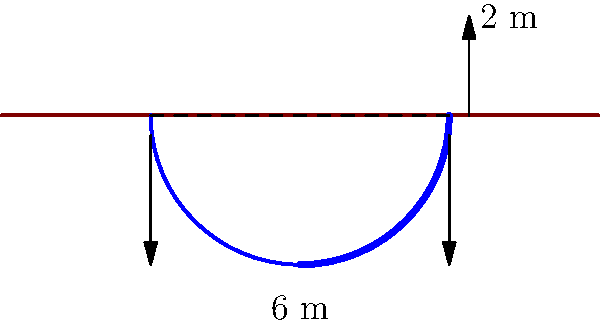During an excavation of an ancient fortress, you discover a partially buried cylindrical structure. The visible arc of the structure rises 2 meters above the ground, and the diameter of the base is 6 meters. Estimate the total volume of the cylindrical structure, assuming it extends uniformly below the ground. Round your answer to the nearest cubic meter. To estimate the volume of the cylindrical structure, we'll follow these steps:

1) First, we need to find the radius (r) of the base:
   Diameter = 6 m, so radius = 6/2 = 3 m

2) Next, we need to find the height (h) of the cylinder. We can do this using the Pythagorean theorem:
   $r^2 + (r-2)^2 = r^2$
   $3^2 + (3-2)^2 = 3^2$
   $9 + 1 = 9$
   
   This confirms that the visible part forms a right angle with the ground.

3) The total height is the diameter: h = 6 m

4) Now we can use the formula for the volume of a cylinder:
   $V = \pi r^2 h$

5) Plugging in our values:
   $V = \pi \cdot 3^2 \cdot 6$
   $V = \pi \cdot 9 \cdot 6$
   $V = 54\pi$

6) Calculating and rounding to the nearest cubic meter:
   $V \approx 169.65 \approx 170$ cubic meters

Therefore, the estimated volume of the cylindrical structure is approximately 170 cubic meters.
Answer: 170 cubic meters 